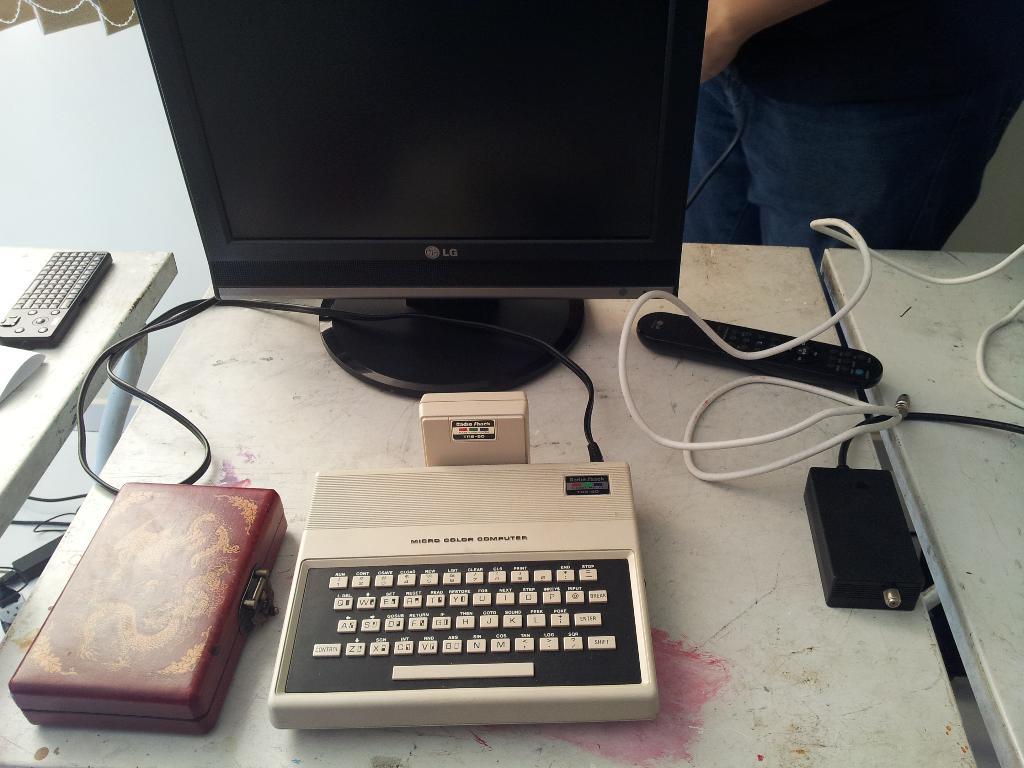What brand of computer is this?
Keep it short and to the point. Lg. What model is this computer?
Make the answer very short. Unanswerable. 